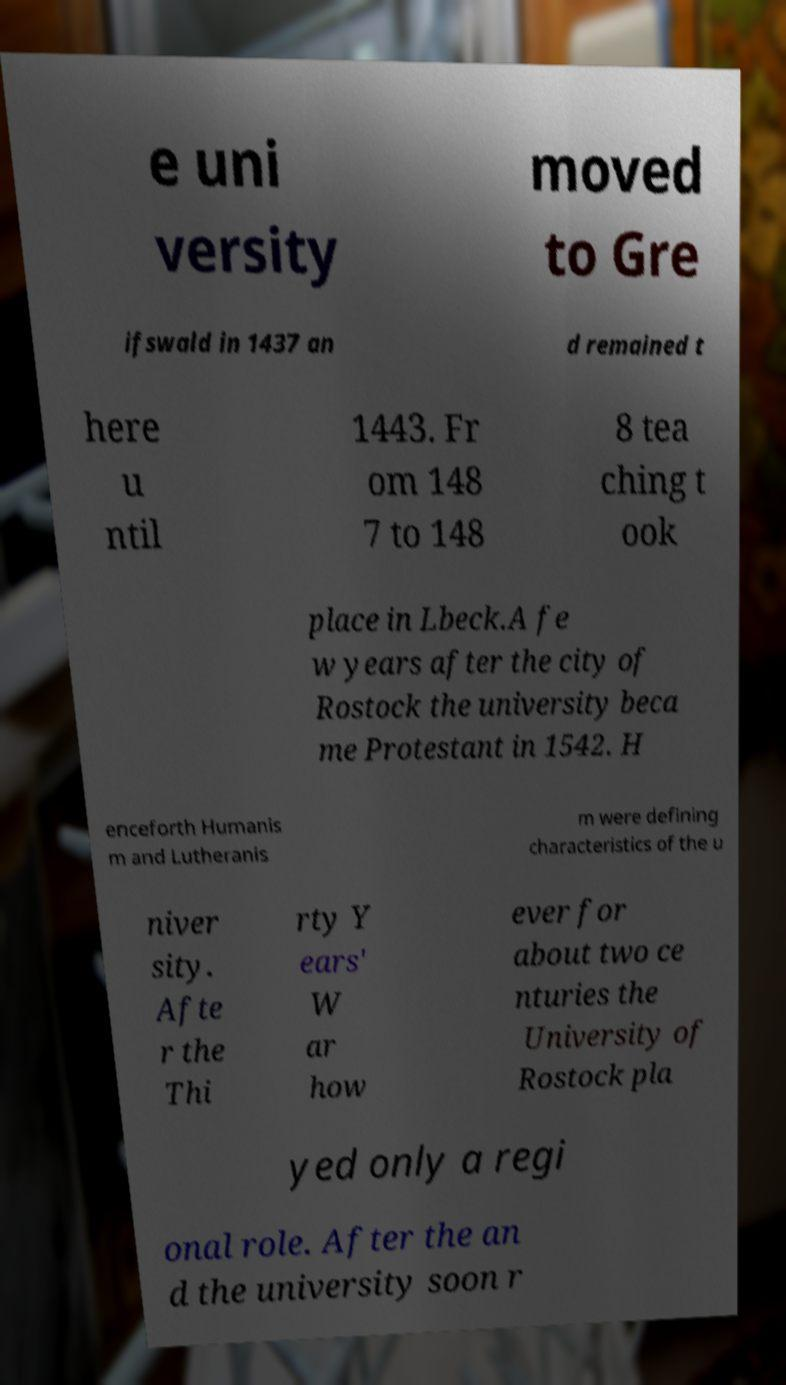Please identify and transcribe the text found in this image. e uni versity moved to Gre ifswald in 1437 an d remained t here u ntil 1443. Fr om 148 7 to 148 8 tea ching t ook place in Lbeck.A fe w years after the city of Rostock the university beca me Protestant in 1542. H enceforth Humanis m and Lutheranis m were defining characteristics of the u niver sity. Afte r the Thi rty Y ears' W ar how ever for about two ce nturies the University of Rostock pla yed only a regi onal role. After the an d the university soon r 